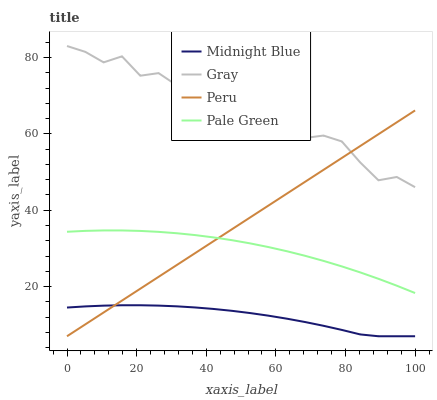Does Midnight Blue have the minimum area under the curve?
Answer yes or no. Yes. Does Gray have the maximum area under the curve?
Answer yes or no. Yes. Does Pale Green have the minimum area under the curve?
Answer yes or no. No. Does Pale Green have the maximum area under the curve?
Answer yes or no. No. Is Peru the smoothest?
Answer yes or no. Yes. Is Gray the roughest?
Answer yes or no. Yes. Is Pale Green the smoothest?
Answer yes or no. No. Is Pale Green the roughest?
Answer yes or no. No. Does Midnight Blue have the lowest value?
Answer yes or no. Yes. Does Pale Green have the lowest value?
Answer yes or no. No. Does Gray have the highest value?
Answer yes or no. Yes. Does Pale Green have the highest value?
Answer yes or no. No. Is Midnight Blue less than Gray?
Answer yes or no. Yes. Is Gray greater than Midnight Blue?
Answer yes or no. Yes. Does Peru intersect Gray?
Answer yes or no. Yes. Is Peru less than Gray?
Answer yes or no. No. Is Peru greater than Gray?
Answer yes or no. No. Does Midnight Blue intersect Gray?
Answer yes or no. No. 